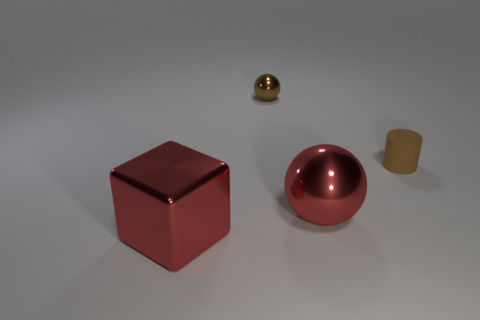Is there any other thing that has the same material as the brown cylinder?
Provide a short and direct response. No. The shiny thing that is on the left side of the large sphere and in front of the matte thing has what shape?
Provide a succinct answer. Cube. What is the size of the other red metallic object that is the same shape as the small metallic thing?
Make the answer very short. Large. Is the number of big red metal cubes that are on the right side of the tiny rubber cylinder less than the number of red things?
Offer a terse response. Yes. What is the size of the thing that is behind the cylinder?
Your answer should be compact. Small. There is another shiny object that is the same shape as the brown metal thing; what color is it?
Give a very brief answer. Red. How many tiny objects are the same color as the metal block?
Keep it short and to the point. 0. Is there any other thing that has the same shape as the brown metal thing?
Your answer should be compact. Yes. There is a brown thing that is on the left side of the large red shiny thing behind the red block; are there any red metallic spheres that are on the left side of it?
Ensure brevity in your answer.  No. How many red blocks have the same material as the brown ball?
Offer a very short reply. 1. 